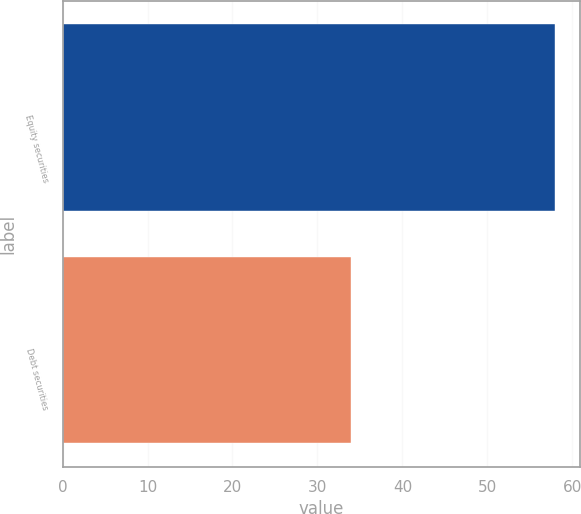Convert chart to OTSL. <chart><loc_0><loc_0><loc_500><loc_500><bar_chart><fcel>Equity securities<fcel>Debt securities<nl><fcel>58<fcel>34<nl></chart> 